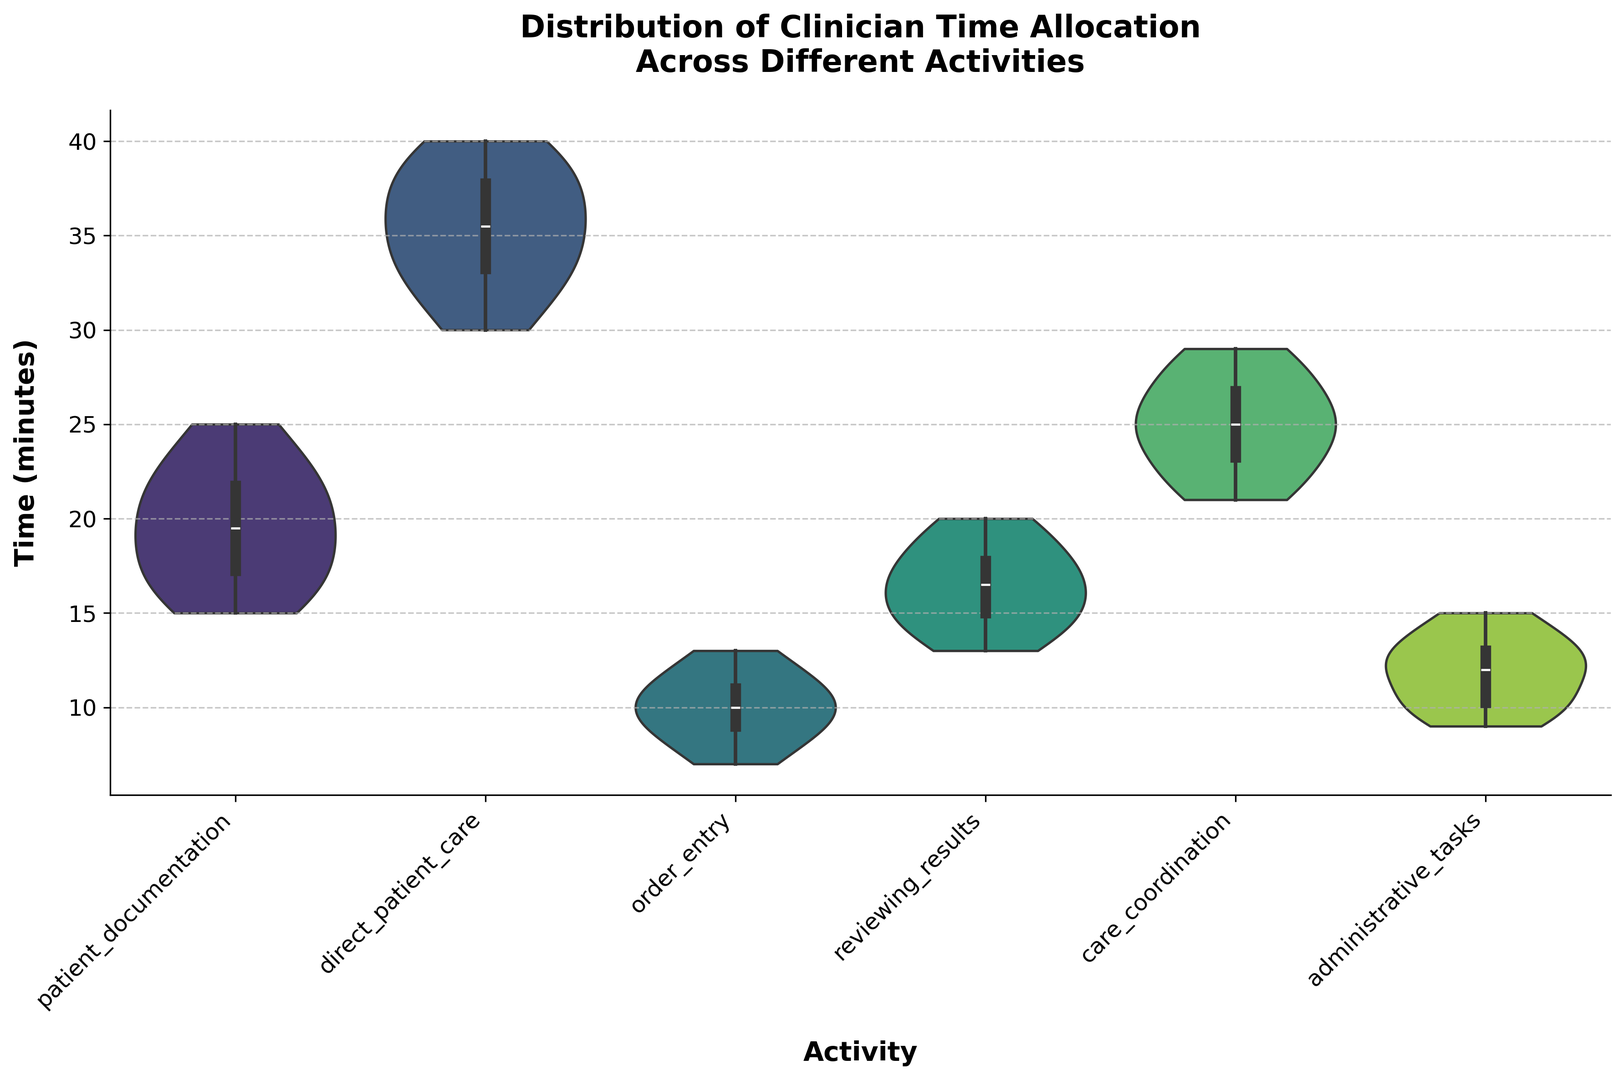Which activity has the widest distribution of time spent? By looking at the violin plots, we can assess the width of each distribution. The widest distribution will span the most minutes from the bottom to the top of the plot.
Answer: Direct patient care Which activity has the narrowest distribution of time spent? By comparing the width of the distributions for each activity, we can determine that the activity with the least variance in time will have the narrowest plot.
Answer: Order entry Which activity's time allocation median is closest to 24 minutes? The median of each activity's time is represented by the white dot inside the violin plots.
Answer: Care coordination Is the median time spent on patient documentation greater than on administrative tasks? We compare the white dots (medians) for both patient documentation and administrative tasks plots to see which is higher.
Answer: Yes Which activity has both the highest and the lowest outlier? The highest and lowest dots that occur outside the main body of the violin plot represent the outliers. By observing these, we can determine which activity has outliers at both ends of the spectrum.
Answer: Direct patient care What is the approximate range of time spent on reviewing results? The range can be determined by looking at the minimum and maximum points of the violin plot for reviewing results.
Answer: 13-20 minutes Is the interquartile range (IQR) of time spent on patient documentation larger than that of care coordination? The IQR is the range between the 25th and 75th percentiles, which can be observed from the width of the box inside the violin plots for both activities.
Answer: No How does the distribution of time spent on order entry compare to administrative tasks? By observing the shapes and spans of the violin plots, one can compare the variance and central tendency of time spent on order entry versus administrative tasks.
Answer: Order entry has a narrower and more symmetrical distribution What is the typical time allocation for direct patient care? The typical or most frequently occurring time can be inferred from the widest part of the violin plot where it bulges out the most.
Answer: Around 35 minutes Which activity shows the most symmetric distribution of time spent? Symmetry can be assessed by observing how evenly the violin plot is shaped around its median line.
Answer: Administrative tasks 